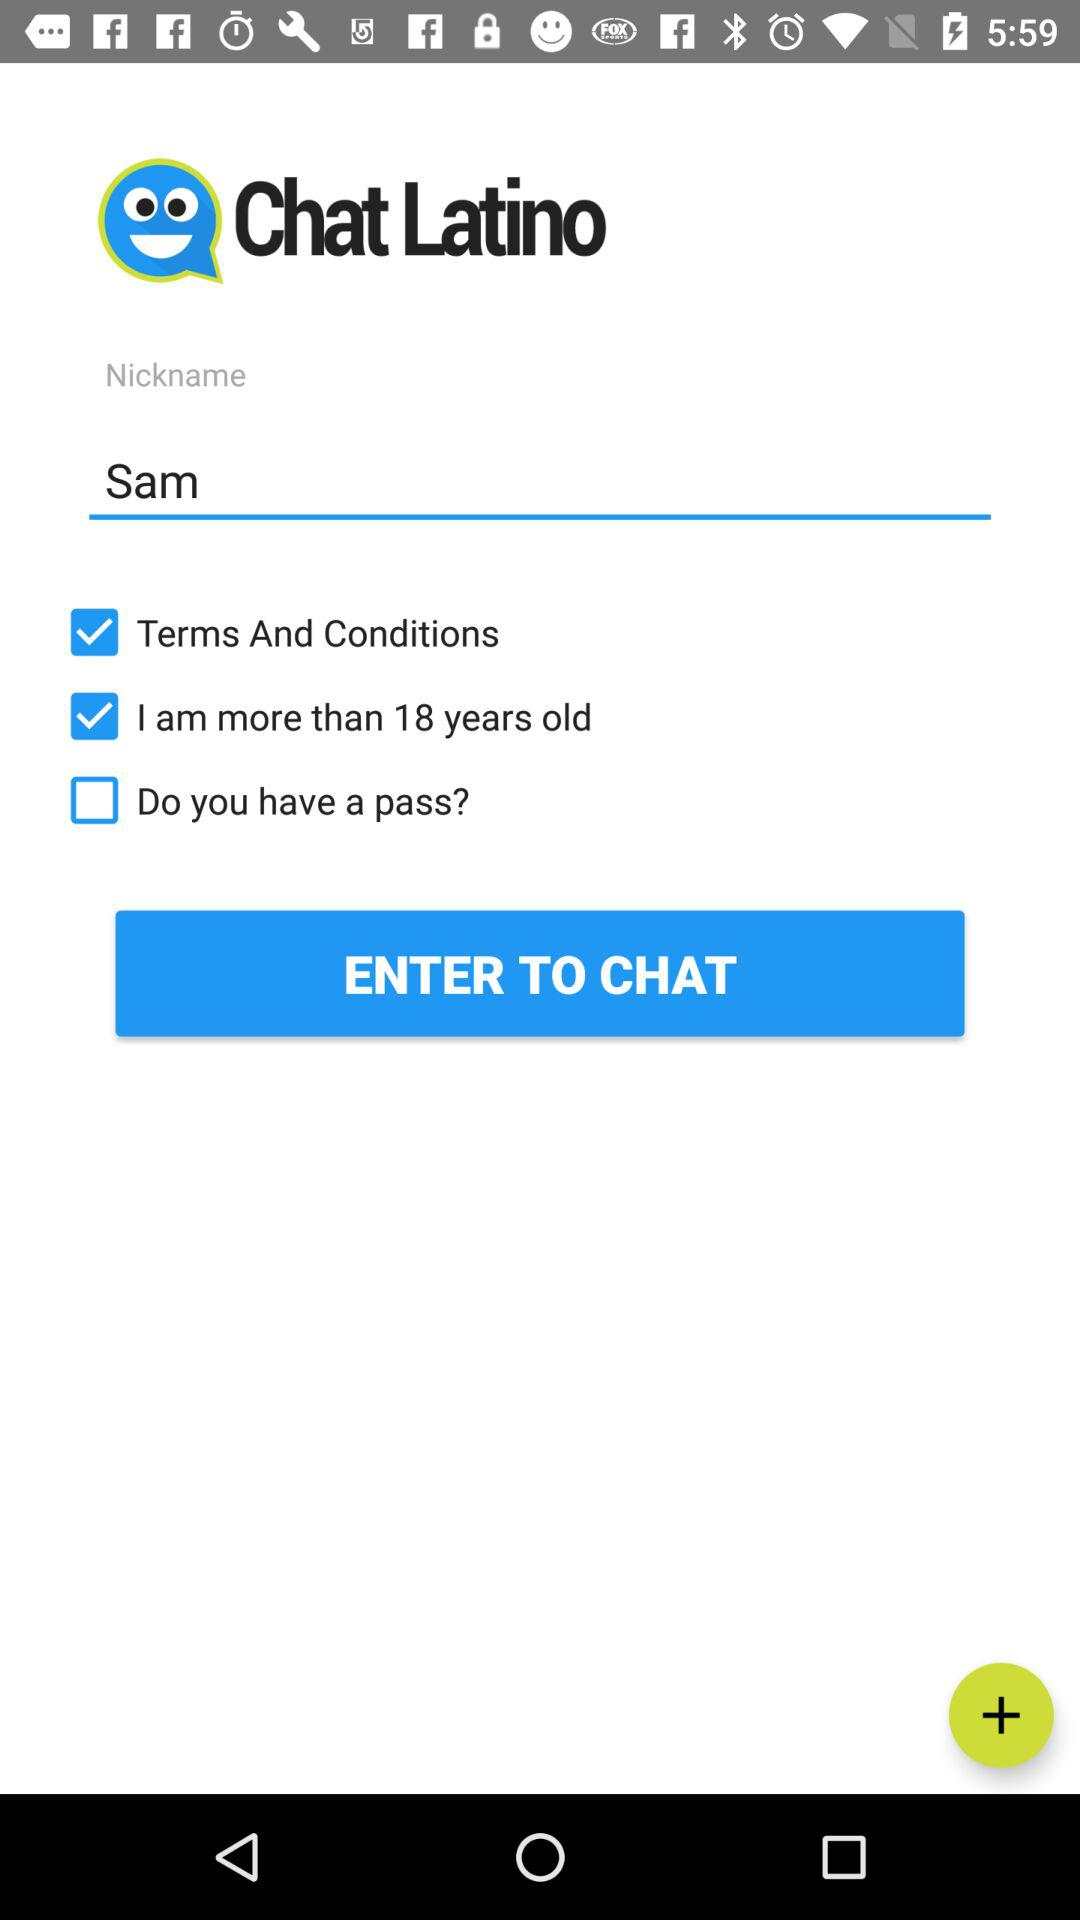What is the application name? The application name is "Chat Latino". 